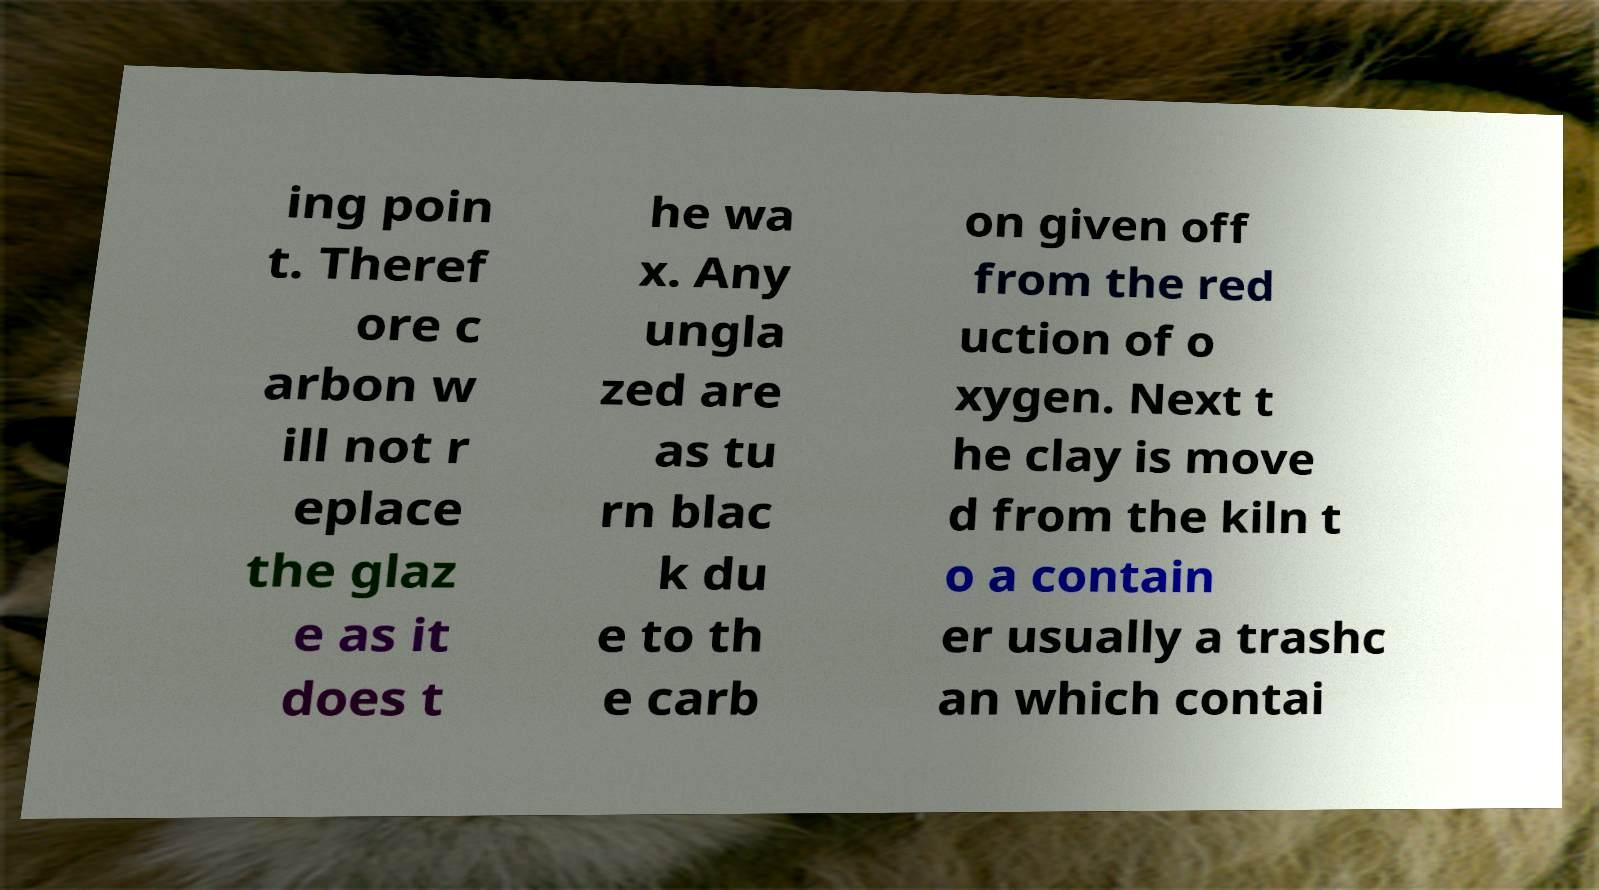For documentation purposes, I need the text within this image transcribed. Could you provide that? ing poin t. Theref ore c arbon w ill not r eplace the glaz e as it does t he wa x. Any ungla zed are as tu rn blac k du e to th e carb on given off from the red uction of o xygen. Next t he clay is move d from the kiln t o a contain er usually a trashc an which contai 